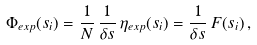Convert formula to latex. <formula><loc_0><loc_0><loc_500><loc_500>\Phi _ { e x p } ( s _ { i } ) = \frac { 1 } { N } \, \frac { 1 } { \delta s } \, \eta _ { e x p } ( s _ { i } ) = \frac { 1 } { \delta s } \, F ( s _ { i } ) \, ,</formula> 